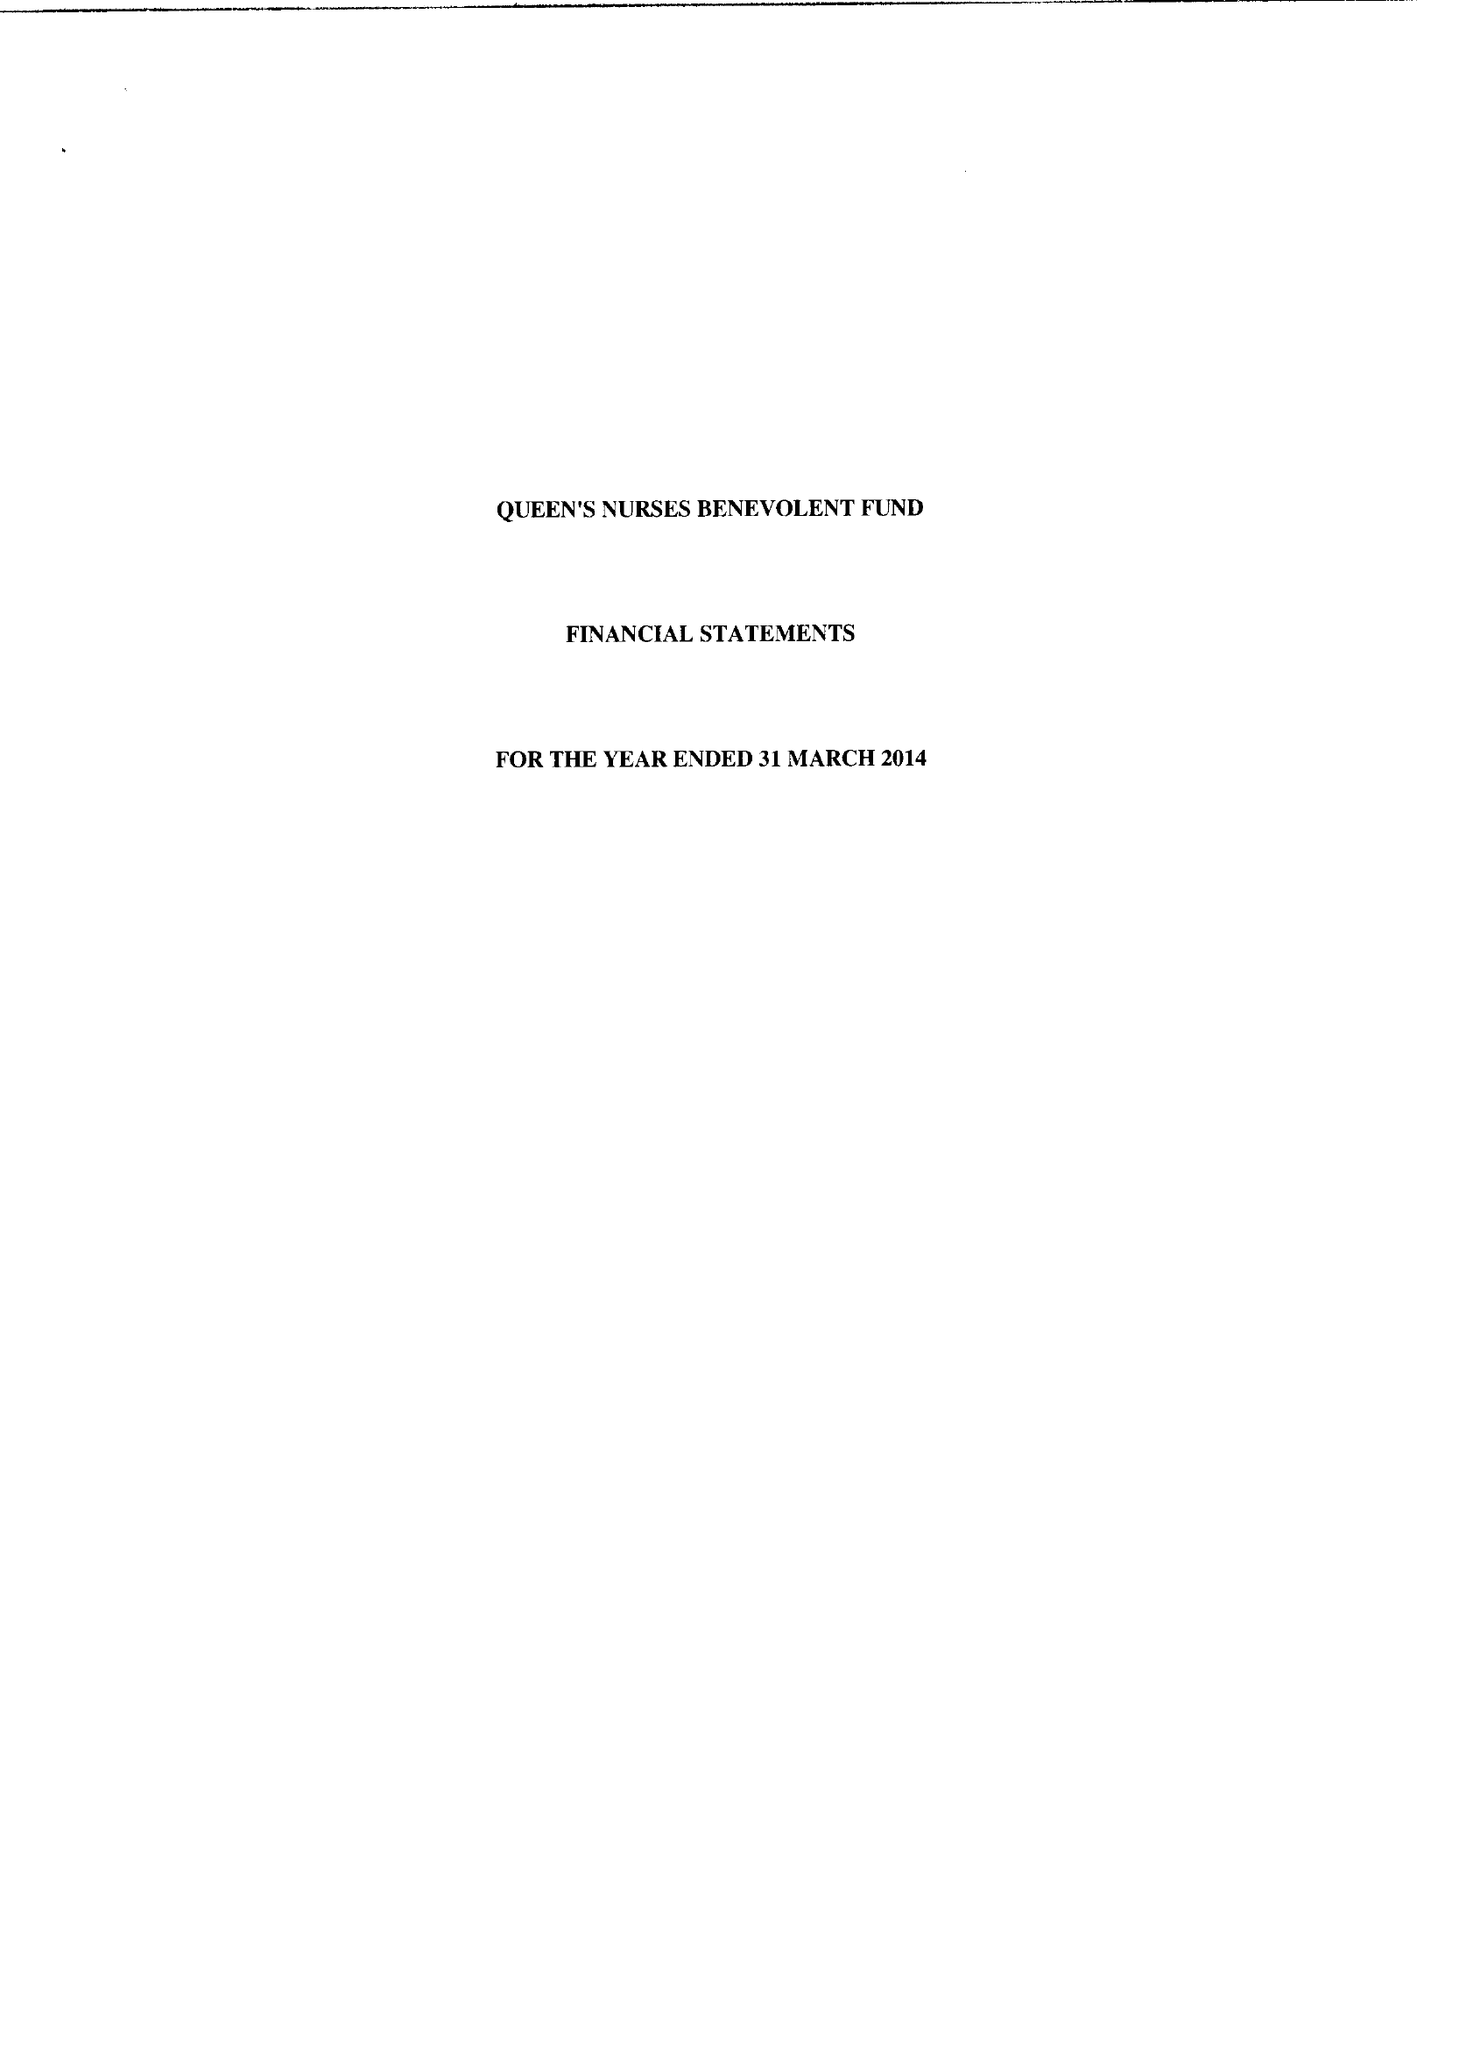What is the value for the charity_name?
Answer the question using a single word or phrase. Queen's Nurses' Benevolent Fund (Incorporating Nurses Holding The National District Nursing Certificate) 